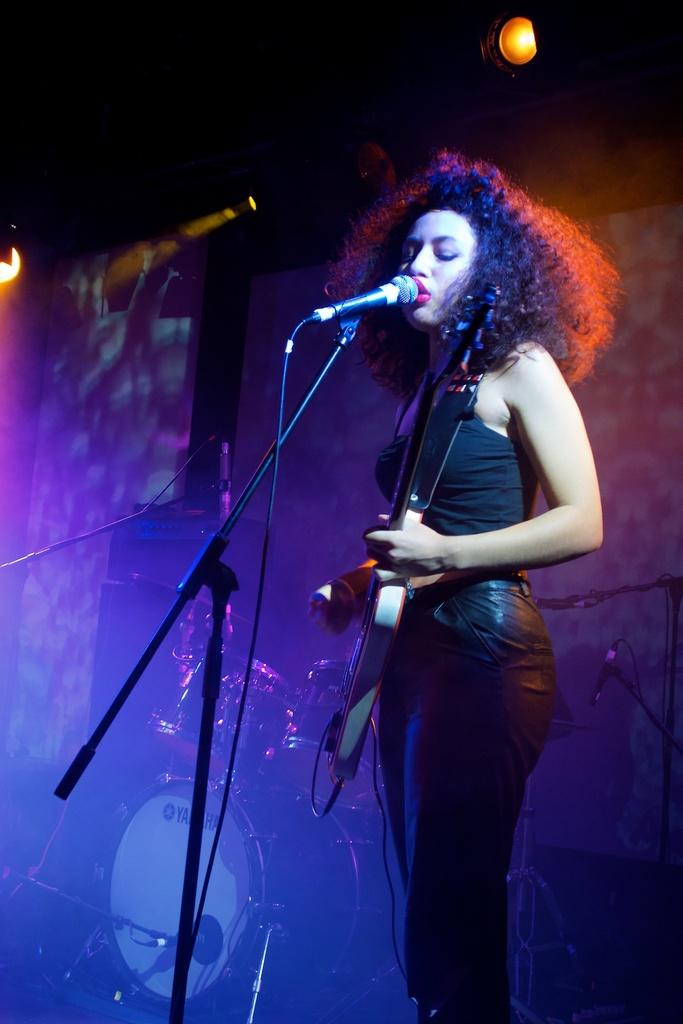What can be seen in the image that provides illumination? There is a light in the image. What is the woman in the image doing? The woman is standing in front of a microphone and singing. What musical instrument is the woman playing? The woman is playing a guitar. What other musical instrument is present in the image? There are drums in the image. What type of flesh can be seen on the woman's hands in the image? There is no visible flesh on the woman's hands in the image; she is wearing gloves. Is there a birthday celebration happening in the image? There is no indication of a birthday celebration in the image. 